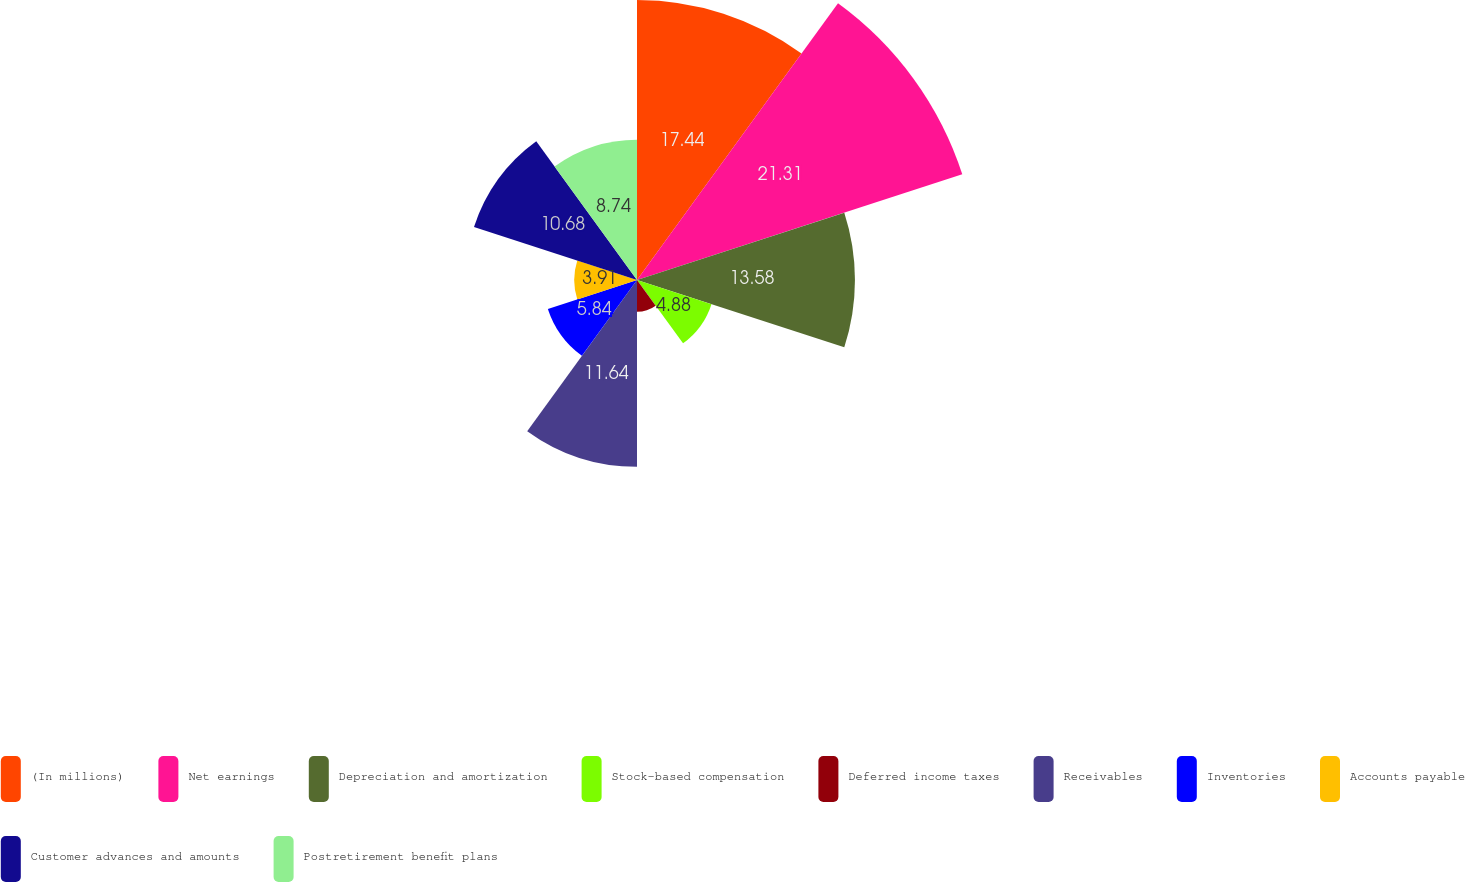Convert chart to OTSL. <chart><loc_0><loc_0><loc_500><loc_500><pie_chart><fcel>(In millions)<fcel>Net earnings<fcel>Depreciation and amortization<fcel>Stock-based compensation<fcel>Deferred income taxes<fcel>Receivables<fcel>Inventories<fcel>Accounts payable<fcel>Customer advances and amounts<fcel>Postretirement benefit plans<nl><fcel>17.44%<fcel>21.31%<fcel>13.58%<fcel>4.88%<fcel>1.98%<fcel>11.64%<fcel>5.84%<fcel>3.91%<fcel>10.68%<fcel>8.74%<nl></chart> 